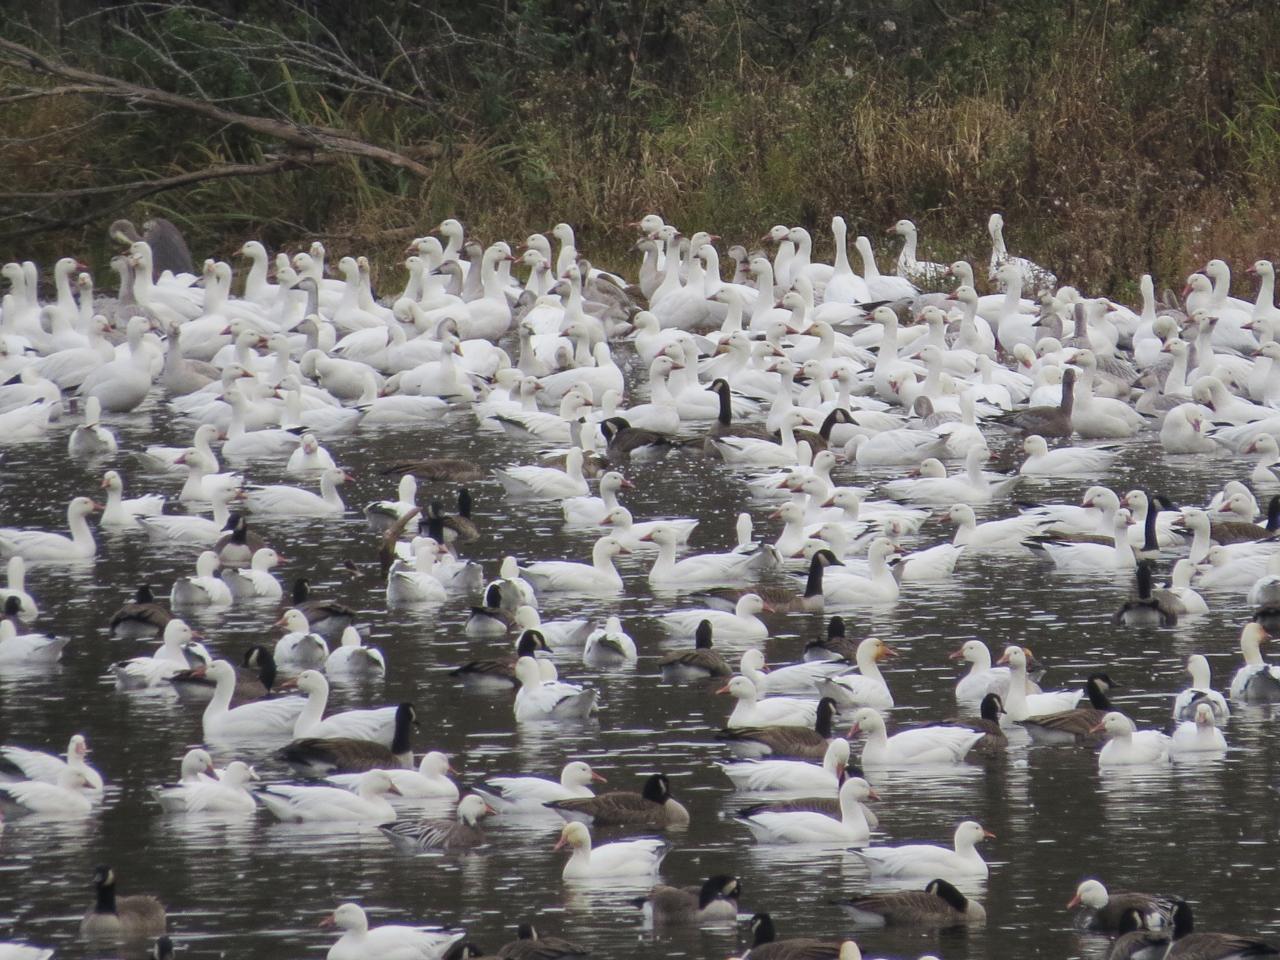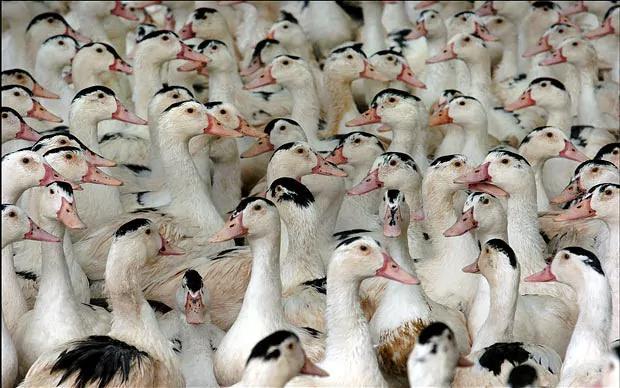The first image is the image on the left, the second image is the image on the right. For the images shown, is this caption "The left image contains no more than 13 birds." true? Answer yes or no. No. 